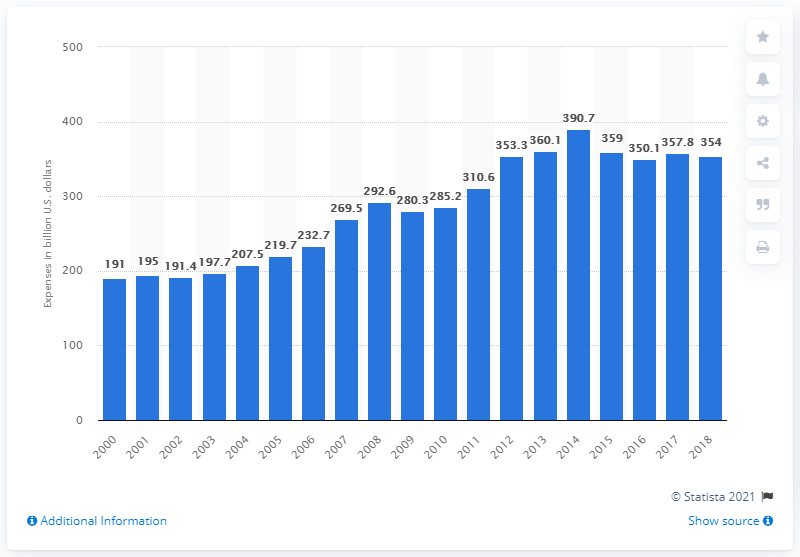Draw attention to some important aspects in this diagram. In 2018, the total amount of farm production expenses in the United States was 354. 